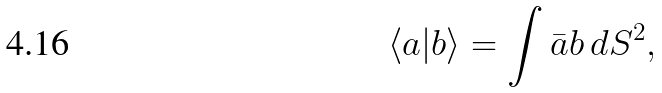Convert formula to latex. <formula><loc_0><loc_0><loc_500><loc_500>\langle a | b \rangle = \int \bar { a } b \, d S ^ { 2 } ,</formula> 